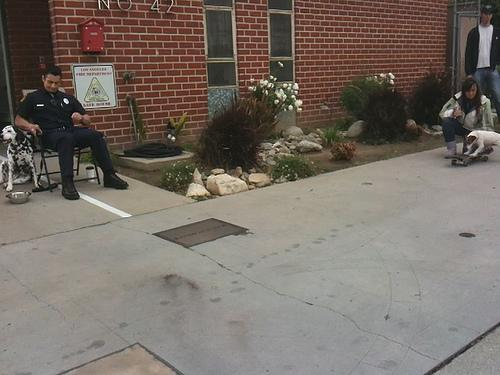Who is the man sitting by the building entrance? Please explain your reasoning. security guard. The man is a security guard in uniform. 